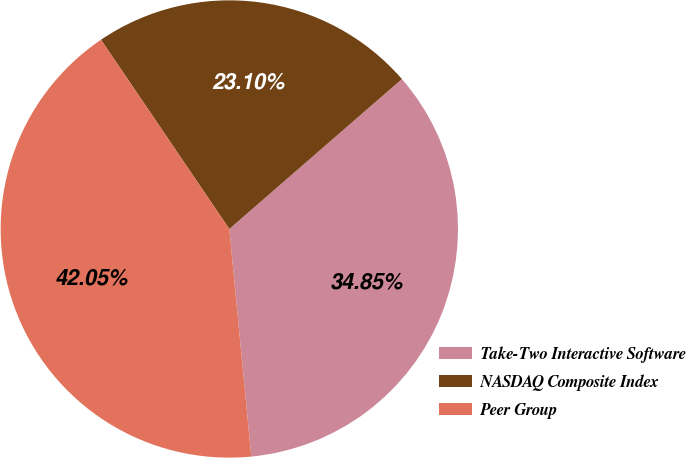Convert chart. <chart><loc_0><loc_0><loc_500><loc_500><pie_chart><fcel>Take-Two Interactive Software<fcel>NASDAQ Composite Index<fcel>Peer Group<nl><fcel>34.85%<fcel>23.1%<fcel>42.05%<nl></chart> 